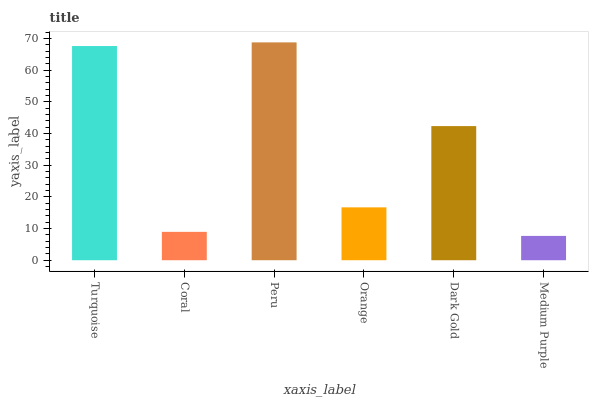Is Medium Purple the minimum?
Answer yes or no. Yes. Is Peru the maximum?
Answer yes or no. Yes. Is Coral the minimum?
Answer yes or no. No. Is Coral the maximum?
Answer yes or no. No. Is Turquoise greater than Coral?
Answer yes or no. Yes. Is Coral less than Turquoise?
Answer yes or no. Yes. Is Coral greater than Turquoise?
Answer yes or no. No. Is Turquoise less than Coral?
Answer yes or no. No. Is Dark Gold the high median?
Answer yes or no. Yes. Is Orange the low median?
Answer yes or no. Yes. Is Peru the high median?
Answer yes or no. No. Is Peru the low median?
Answer yes or no. No. 